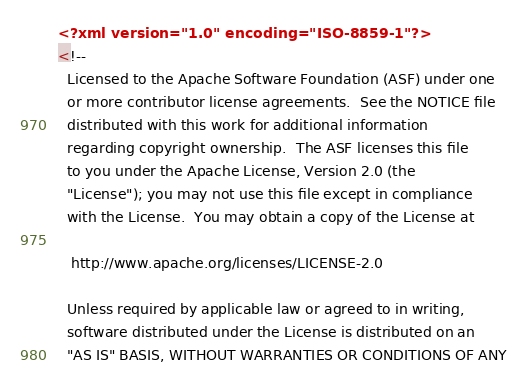<code> <loc_0><loc_0><loc_500><loc_500><_XML_><?xml version="1.0" encoding="ISO-8859-1"?>
<!--
  Licensed to the Apache Software Foundation (ASF) under one
  or more contributor license agreements.  See the NOTICE file
  distributed with this work for additional information
  regarding copyright ownership.  The ASF licenses this file
  to you under the Apache License, Version 2.0 (the
  "License"); you may not use this file except in compliance
  with the License.  You may obtain a copy of the License at

   http://www.apache.org/licenses/LICENSE-2.0

  Unless required by applicable law or agreed to in writing,
  software distributed under the License is distributed on an
  "AS IS" BASIS, WITHOUT WARRANTIES OR CONDITIONS OF ANY</code> 